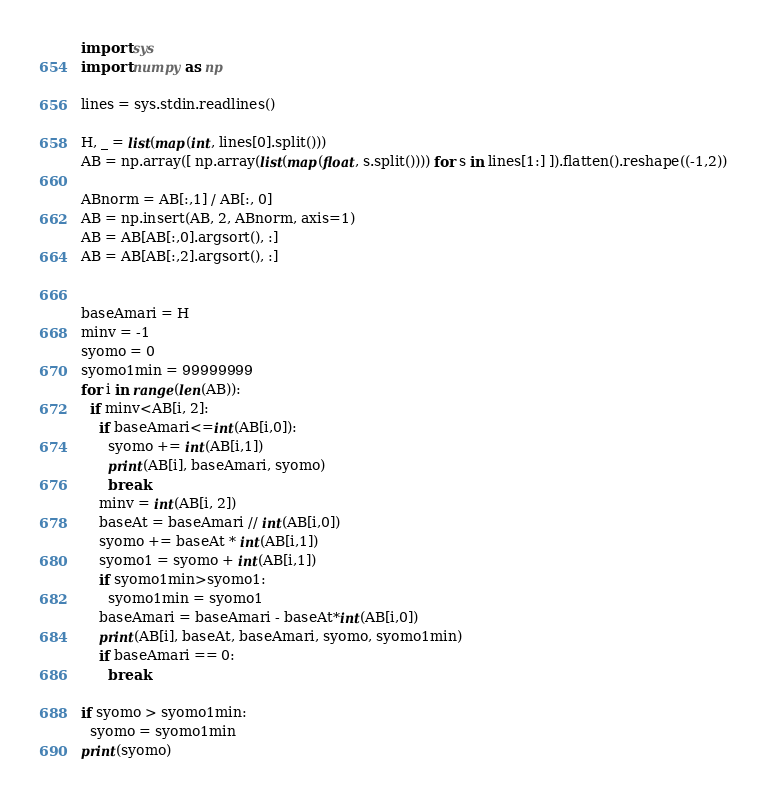Convert code to text. <code><loc_0><loc_0><loc_500><loc_500><_Python_>import sys
import numpy as np

lines = sys.stdin.readlines()

H, _ = list(map(int, lines[0].split()))
AB = np.array([ np.array(list(map(float, s.split()))) for s in lines[1:] ]).flatten().reshape((-1,2))

ABnorm = AB[:,1] / AB[:, 0]
AB = np.insert(AB, 2, ABnorm, axis=1)
AB = AB[AB[:,0].argsort(), :]
AB = AB[AB[:,2].argsort(), :]


baseAmari = H
minv = -1
syomo = 0
syomo1min = 99999999
for i in range(len(AB)):
  if minv<AB[i, 2]:
    if baseAmari<=int(AB[i,0]):
      syomo += int(AB[i,1])
      print(AB[i], baseAmari, syomo)
      break      
    minv = int(AB[i, 2])
    baseAt = baseAmari // int(AB[i,0])
    syomo += baseAt * int(AB[i,1])
    syomo1 = syomo + int(AB[i,1])
    if syomo1min>syomo1:
      syomo1min = syomo1
    baseAmari = baseAmari - baseAt*int(AB[i,0])
    print(AB[i], baseAt, baseAmari, syomo, syomo1min)
    if baseAmari == 0:
      break

if syomo > syomo1min:
  syomo = syomo1min
print(syomo)

</code> 